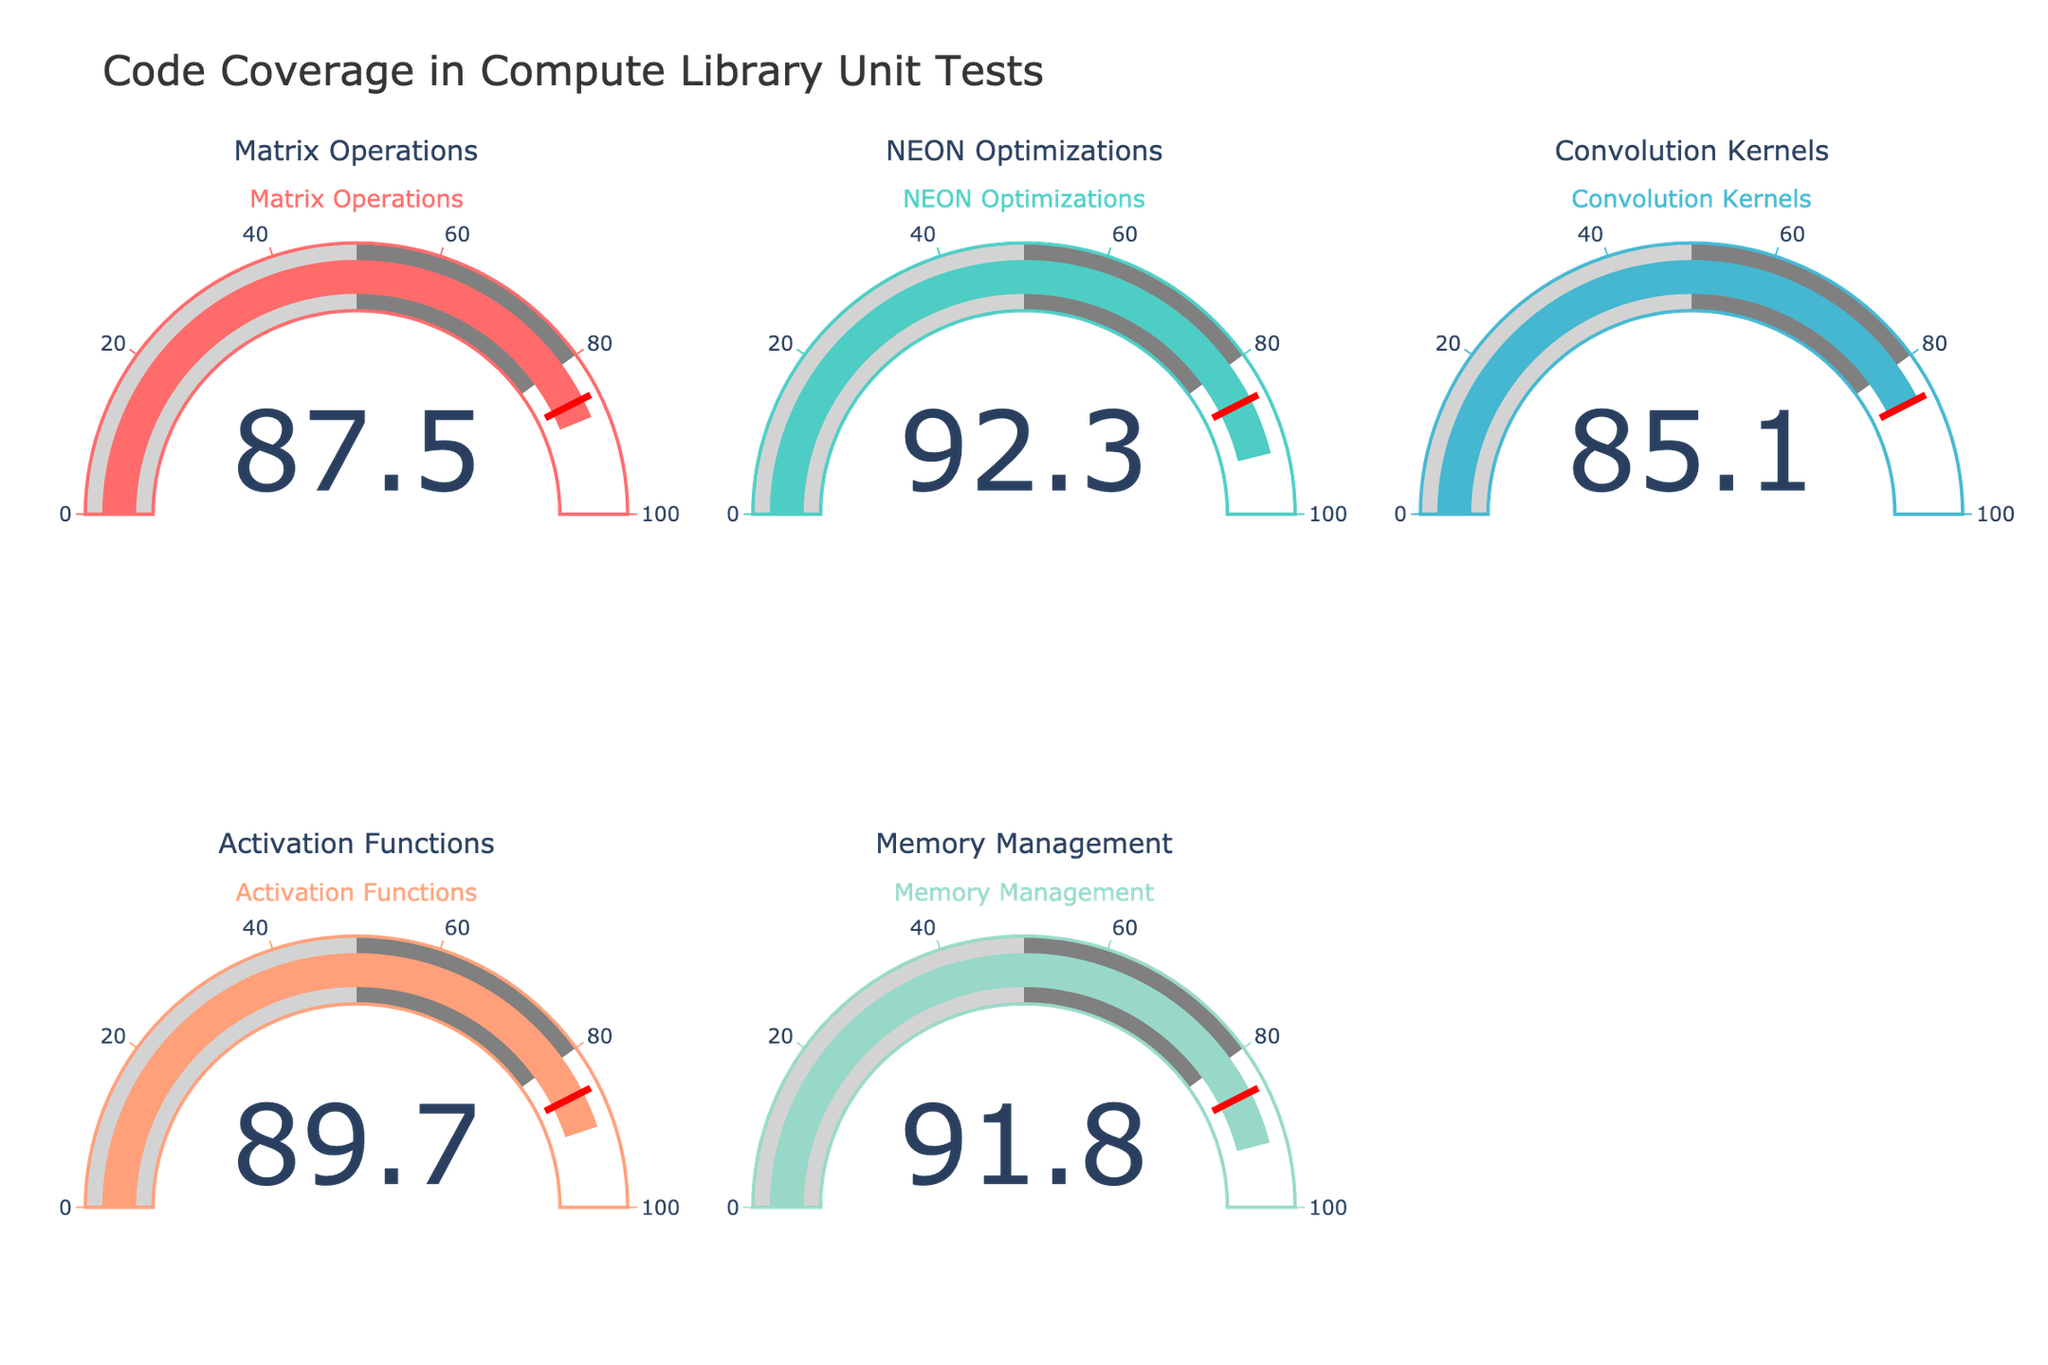What's the overall title of the figure? The overall title is located at the top center of the figure and reads "Code Coverage in Compute Library Unit Tests".
Answer: Code Coverage in Compute Library Unit Tests How many components are being tested for code coverage? Each gauge represents one component, and there are a total of five gauges. Therefore, five components are being tested.
Answer: 5 Which component has the highest code coverage? By visually inspecting each gauge, the NEON Optimizations component has the highest value which is 92.3%.
Answer: NEON Optimizations What is the average code coverage across all components? Sum up all the coverage values: 87.5 + 92.3 + 85.1 + 89.7 + 91.8 = 446.4. Then, divide by the number of components: 446.4 / 5 = 89.28%.
Answer: 89.28% Which component has the lowest code coverage? By looking at the gauges, the Convolution Kernels component has the lowest coverage at 85.1%.
Answer: Convolution Kernels How much higher is the code coverage of NEON Optimizations compared to Matrix Operations? Subtract the coverage of Matrix Operations from NEON Optimizations: 92.3 - 87.5 = 4.8%.
Answer: 4.8% What is the range of code coverage values? The highest value is 92.3% and the lowest is 85.1%. The range is calculated as 92.3 - 85.1 = 7.2%.
Answer: 7.2% How many components have a code coverage above 90%? Visually inspecting the gauges, NEON Optimizations, and Memory Management have coverage above 90%. Thus, there are 2 components.
Answer: 2 What is the median value of the code coverage? The sorted values are 85.1, 87.5, 89.7, 91.8, and 92.3. The median value is the third number in this sorted list: 89.7.
Answer: 89.7 Does any component's code coverage fall below the threshold value of 85%? By visually inspecting the gauges, no component has a code coverage below the threshold value of 85%.
Answer: No 